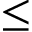<formula> <loc_0><loc_0><loc_500><loc_500>\leq</formula> 